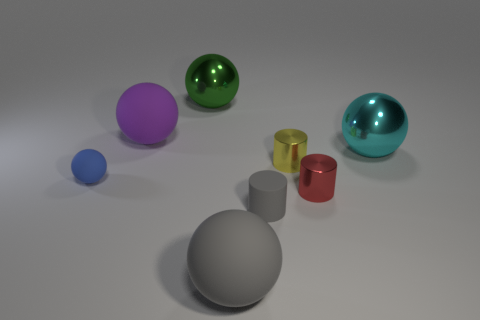Subtract all small blue rubber spheres. How many spheres are left? 4 Subtract all gray balls. How many balls are left? 4 Subtract 1 cylinders. How many cylinders are left? 2 Add 1 large purple balls. How many objects exist? 9 Subtract 1 gray spheres. How many objects are left? 7 Subtract all cylinders. How many objects are left? 5 Subtract all yellow balls. Subtract all yellow cylinders. How many balls are left? 5 Subtract all gray cylinders. How many yellow balls are left? 0 Subtract all cyan shiny spheres. Subtract all red cylinders. How many objects are left? 6 Add 8 red cylinders. How many red cylinders are left? 9 